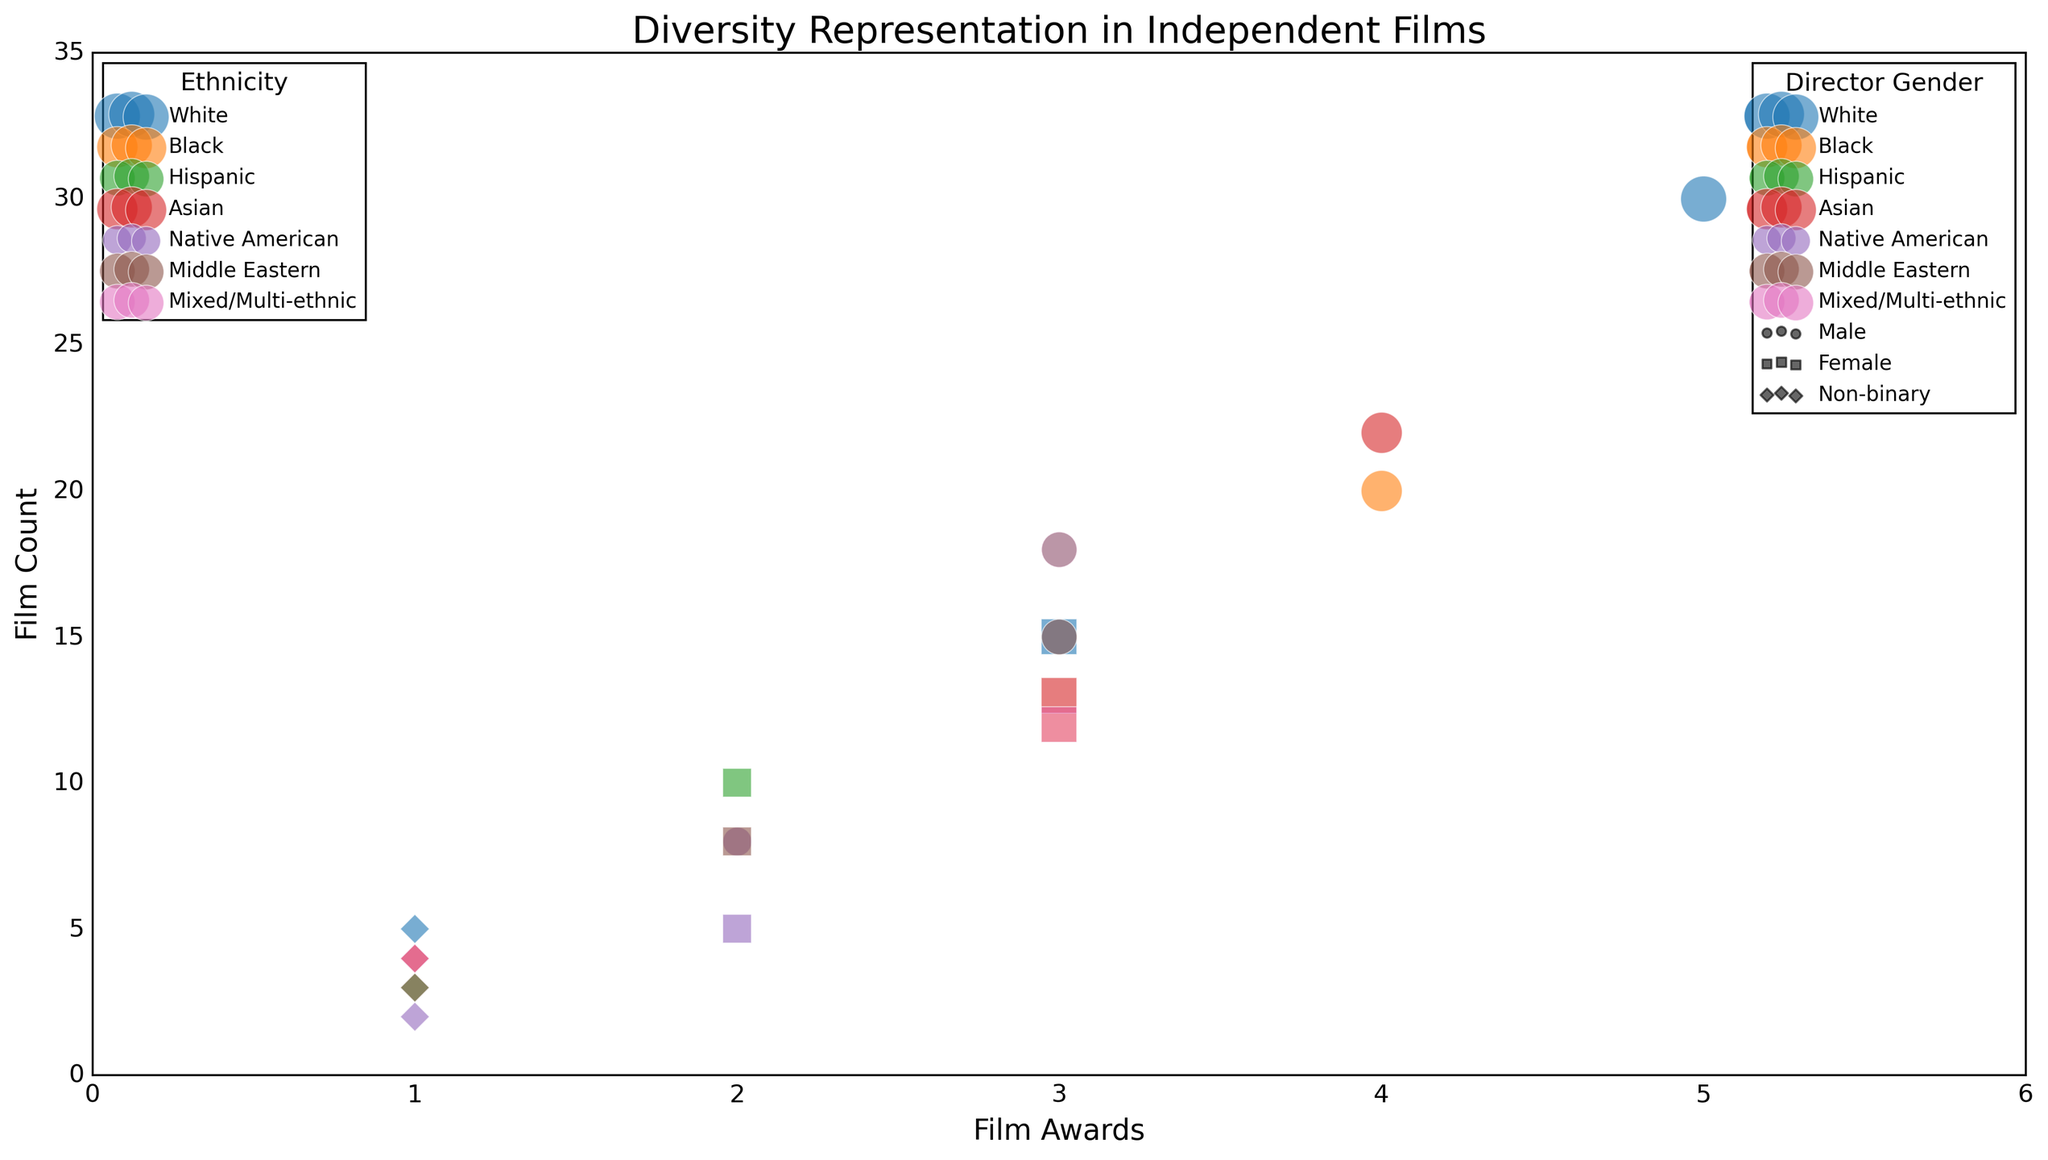What ethnicity has the highest total film awards? To find the ethnicity with the highest total film awards, sum the film awards for each ethnicity, then compare the sums. White: 5 + 3 + 1 = 9; Black: 4 + 3 + 1 = 8; Hispanic: 3 + 2 + 1 = 6; Asian: 4 + 3 + 1 = 8; Native American: 2 + 2 + 1 = 5; Middle Eastern: 3 + 2 + 1 = 6; Mixed/Multi-ethnic: 3 + 3 + 1 = 7. Therefore, the White ethnicity has the highest total film awards.
Answer: White Which director gender has the most films awarded 4 or more awards? Count the number of films awarded 4 or more awards for each director gender. Males: White (0), Black (1), Hispanic (0), Asian (1), Native American (0), Middle Eastern (0), Mixed/Multi-ethnic (0). Females: White (0), Black (0), Hispanic (0), Asian (0), Native American (0), Middle Eastern (0), Mixed/Multi-ethnic (0). Non-binary: White (0), Black (0), Hispanic (0), Asian (0), Native American (0), Middle Eastern (0), Mixed/Multi-ethnic (0). Only Male directors have films with 4 or more awards.
Answer: Male Which ethnicity and director gender combination has the least total film count? For each ethnicity and director gender combination, sum the film counts. Find the minimum total film count among all combinations. White, Non-binary: 5; Black, Non-binary: 4; Hispanic, Non-binary: 3; Asian, Non-binary: 4; Native American, Non-binary: 2; Middle Eastern, Non-binary: 3; Mixed/Multi-ethnic, Non-binary: 4. The combination with the least total film count is Native American, Non-binary.
Answer: Native American, Non-binary Among females, which ethnicity has the highest film count for films awarded 3 film awards? Identify the ethnicities with females that have films awarded 3 film awards, then compare their film counts. White: 15; Black: 12; Hispanic: 10; Asian: 13; Middle Eastern: 8; Mixed/Multi-ethnic: 12. The ethnicity with the highest film count is White.
Answer: White What is the average film count for Male directors of Hispanic films awarded 3 film awards and Female directors of Black films awarded 3 film awards? Summing the film counts: Hispanic, Male (3 awards): 18; Black, Female (3 awards): 12. Average = (18 + 12) / 2 = 15.
Answer: 15 How many more films did Male directors of Black ethnicity receive 4 awards compared to Non-binary directors of White ethnicity receiving 1 award? Black, Male: 20 films (4 awards); White, Non-binary: 5 films (1 award). Difference: 20 - 5 = 15 films.
Answer: 15 Which ethnicity represented by Non-binary directors has the highest total film awards? Compare total film awards among Non-binary directors: White (1), Black (1), Hispanic (1), Asian (1), Native American (1), Middle Eastern (1), Mixed/Multi-ethnic (1). They all have equal film awards (1) each.
Answer: Equal for all How does the film count of Asian Male directors (4 awards) compare to Hispanic Female directors (2 awards)? Asian, Male: 22 films; Hispanic, Female: 10 films. Comparison: 22 > 10.
Answer: Asian Male > Hispanic Female Which director gender has the smallest discrepancy between their highest and lowest film awards? Calculate discrepancies: Male: 5 (White) - 2 (Native American) = 3; Female: 3 (White, Black, Asian, Mixed) - 2 (Native American, Middle Eastern) = 1; Non-binary: 1 (all). The smallest discrepancy is in Non-binary directors.
Answer: Non-binary Which ethnicity has the most diverse range of director genders in films awarded exactly 1 film award? Examine the ethnicities and the director gender count for 1 award: White (Non-binary), Black (Non-binary), Hispanic (Non-binary), Asian (Non-binary), Native American (Non-binary), Middle Eastern (Non-binary), Mixed/Multi-ethnic (Non-binary). Each ethnicity has an equal range (one Non-binary).
Answer: Equal for all 